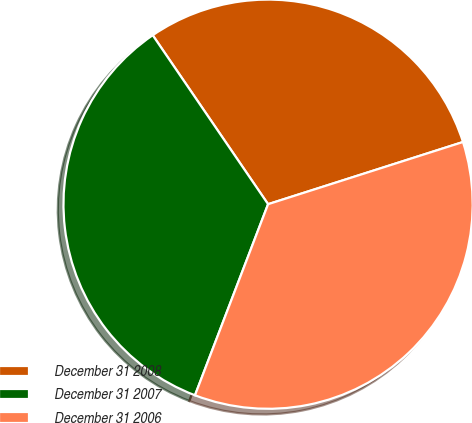Convert chart. <chart><loc_0><loc_0><loc_500><loc_500><pie_chart><fcel>December 31 2008<fcel>December 31 2007<fcel>December 31 2006<nl><fcel>29.62%<fcel>34.65%<fcel>35.73%<nl></chart> 